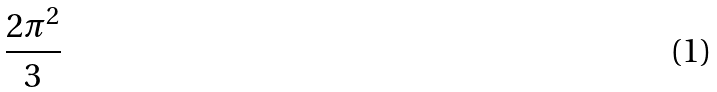Convert formula to latex. <formula><loc_0><loc_0><loc_500><loc_500>\frac { 2 \pi ^ { 2 } } { 3 }</formula> 